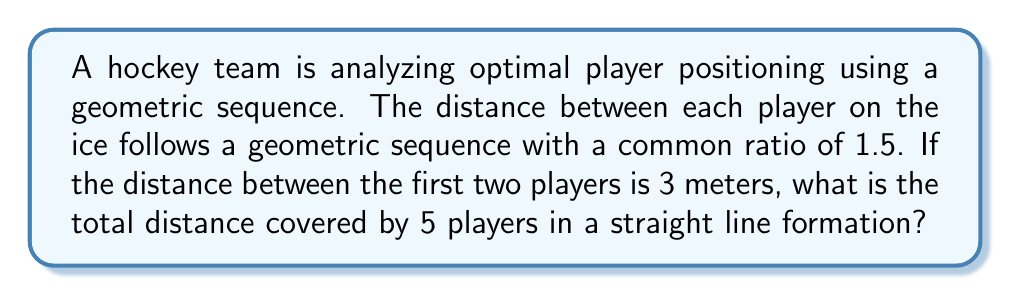Can you solve this math problem? Let's approach this step-by-step:

1) In a geometric sequence, each term is multiplied by a constant (common ratio) to get the next term. Here, the common ratio is 1.5.

2) Let's define the terms of our sequence:
   $a_1 = 3$ (distance between 1st and 2nd player)
   $a_2 = 3 * 1.5 = 4.5$ (distance between 2nd and 3rd player)
   $a_3 = 4.5 * 1.5 = 6.75$ (distance between 3rd and 4th player)
   $a_4 = 6.75 * 1.5 = 10.125$ (distance between 4th and 5th player)

3) The total distance is the sum of these terms:
   $S = a_1 + a_2 + a_3 + a_4$

4) We can use the formula for the sum of a geometric sequence:
   $S_n = \frac{a_1(1-r^n)}{1-r}$, where $a_1$ is the first term, $r$ is the common ratio, and $n$ is the number of terms.

5) In our case:
   $a_1 = 3$
   $r = 1.5$
   $n = 4$ (we have 4 distances between 5 players)

6) Plugging these into our formula:
   $S_4 = \frac{3(1-1.5^4)}{1-1.5}$

7) Simplifying:
   $S_4 = \frac{3(1-5.0625)}{-0.5} = \frac{3(-4.0625)}{-0.5} = 24.375$

Therefore, the total distance covered by 5 players in a straight line formation is 24.375 meters.
Answer: 24.375 meters 